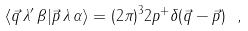Convert formula to latex. <formula><loc_0><loc_0><loc_500><loc_500>\langle \vec { q } \, \lambda ^ { \prime } \, \beta | \vec { p } \, \lambda \, \alpha \rangle = ( 2 \pi ) ^ { 3 } 2 p ^ { + } \delta ( \vec { q } - \vec { p } ) \ ,</formula> 